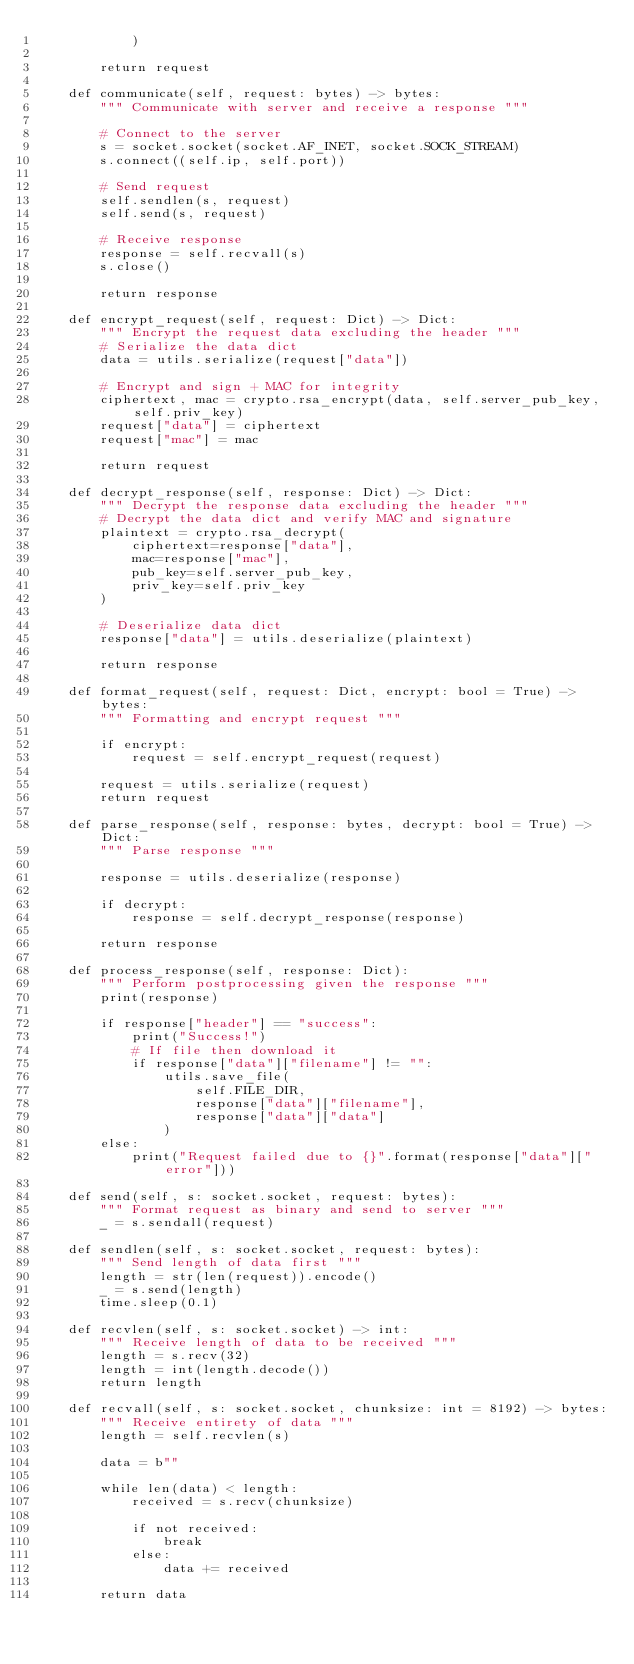<code> <loc_0><loc_0><loc_500><loc_500><_Python_>            )

        return request

    def communicate(self, request: bytes) -> bytes:
        """ Communicate with server and receive a response """

        # Connect to the server
        s = socket.socket(socket.AF_INET, socket.SOCK_STREAM)
        s.connect((self.ip, self.port))

        # Send request
        self.sendlen(s, request)
        self.send(s, request)

        # Receive response
        response = self.recvall(s)
        s.close()

        return response

    def encrypt_request(self, request: Dict) -> Dict:
        """ Encrypt the request data excluding the header """
        # Serialize the data dict
        data = utils.serialize(request["data"])

        # Encrypt and sign + MAC for integrity
        ciphertext, mac = crypto.rsa_encrypt(data, self.server_pub_key, self.priv_key)
        request["data"] = ciphertext
        request["mac"] = mac

        return request

    def decrypt_response(self, response: Dict) -> Dict:
        """ Decrypt the response data excluding the header """
        # Decrypt the data dict and verify MAC and signature
        plaintext = crypto.rsa_decrypt(
            ciphertext=response["data"],
            mac=response["mac"],
            pub_key=self.server_pub_key,
            priv_key=self.priv_key
        )
        
        # Deserialize data dict
        response["data"] = utils.deserialize(plaintext)

        return response

    def format_request(self, request: Dict, encrypt: bool = True) -> bytes:
        """ Formatting and encrypt request """

        if encrypt:
            request = self.encrypt_request(request)

        request = utils.serialize(request)
        return request

    def parse_response(self, response: bytes, decrypt: bool = True) -> Dict:
        """ Parse response """

        response = utils.deserialize(response)

        if decrypt:
            response = self.decrypt_response(response)

        return response

    def process_response(self, response: Dict):
        """ Perform postprocessing given the response """
        print(response)

        if response["header"] == "success":
            print("Success!")
            # If file then download it
            if response["data"]["filename"] != "":
                utils.save_file(
                    self.FILE_DIR,
                    response["data"]["filename"],
                    response["data"]["data"]
                )
        else:
            print("Request failed due to {}".format(response["data"]["error"]))

    def send(self, s: socket.socket, request: bytes):
        """ Format request as binary and send to server """
        _ = s.sendall(request)

    def sendlen(self, s: socket.socket, request: bytes):
        """ Send length of data first """
        length = str(len(request)).encode()
        _ = s.send(length)
        time.sleep(0.1)

    def recvlen(self, s: socket.socket) -> int:
        """ Receive length of data to be received """
        length = s.recv(32)
        length = int(length.decode())
        return length

    def recvall(self, s: socket.socket, chunksize: int = 8192) -> bytes:
        """ Receive entirety of data """
        length = self.recvlen(s)

        data = b""

        while len(data) < length:
            received = s.recv(chunksize)

            if not received:
                break
            else:
                data += received

        return data
</code> 